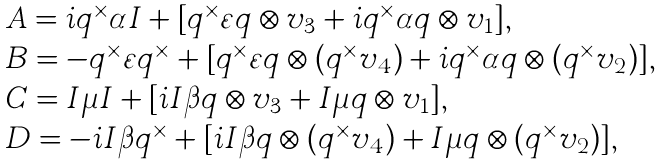Convert formula to latex. <formula><loc_0><loc_0><loc_500><loc_500>\begin{array} { l } A = i q ^ { \times } \alpha I + [ q ^ { \times } \varepsilon q \otimes v _ { 3 } + i q ^ { \times } \alpha q \otimes v _ { 1 } ] , \\ B = - q ^ { \times } \varepsilon q ^ { \times } + [ q ^ { \times } \varepsilon q \otimes ( q ^ { \times } v _ { 4 } ) + i q ^ { \times } \alpha q \otimes ( q ^ { \times } v _ { 2 } ) ] , \\ C = I \mu I + [ i I \beta q \otimes v _ { 3 } + I \mu q \otimes v _ { 1 } ] , \\ D = - i I \beta q ^ { \times } + [ i I \beta q \otimes ( q ^ { \times } v _ { 4 } ) + I \mu q \otimes ( q ^ { \times } v _ { 2 } ) ] , \end{array}</formula> 